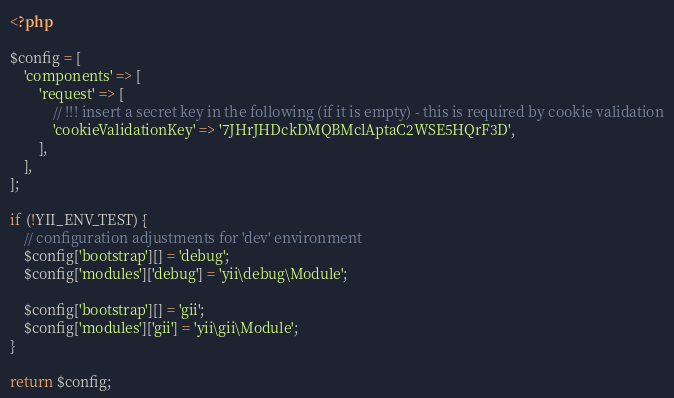<code> <loc_0><loc_0><loc_500><loc_500><_PHP_><?php

$config = [
    'components' => [
        'request' => [
            // !!! insert a secret key in the following (if it is empty) - this is required by cookie validation
            'cookieValidationKey' => '7JHrJHDckDMQBMclAptaC2WSE5HQrF3D',
        ],
    ],
];

if (!YII_ENV_TEST) {
    // configuration adjustments for 'dev' environment
    $config['bootstrap'][] = 'debug';
    $config['modules']['debug'] = 'yii\debug\Module';

    $config['bootstrap'][] = 'gii';
    $config['modules']['gii'] = 'yii\gii\Module';
}

return $config;
</code> 